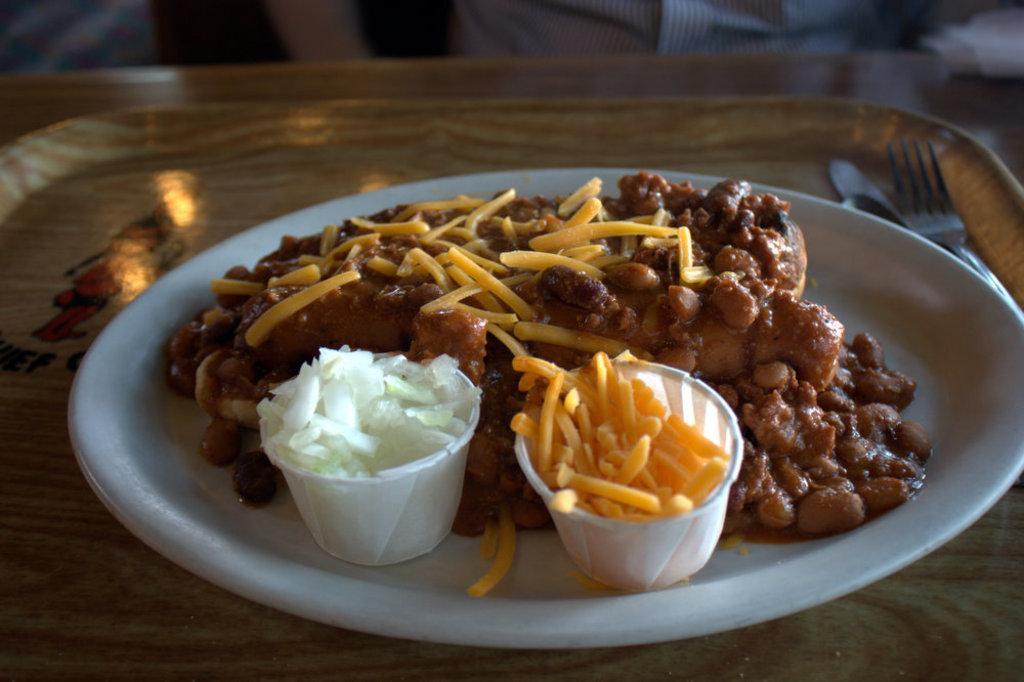In one or two sentences, can you explain what this image depicts? In this image there is a tray on table, on the tray I can see white color plate, on which there is a food and there are bowls, in which there are some ships visible , on the tray there is a fork and spoon visible on right side, at the top I can see a person. 